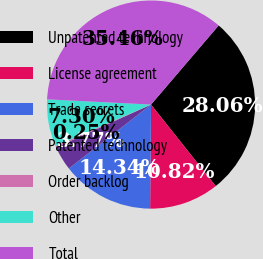<chart> <loc_0><loc_0><loc_500><loc_500><pie_chart><fcel>Unpatented technology<fcel>License agreement<fcel>Trade secrets<fcel>Patented technology<fcel>Order backlog<fcel>Other<fcel>Total<nl><fcel>28.06%<fcel>10.82%<fcel>14.34%<fcel>3.77%<fcel>0.25%<fcel>7.3%<fcel>35.46%<nl></chart> 